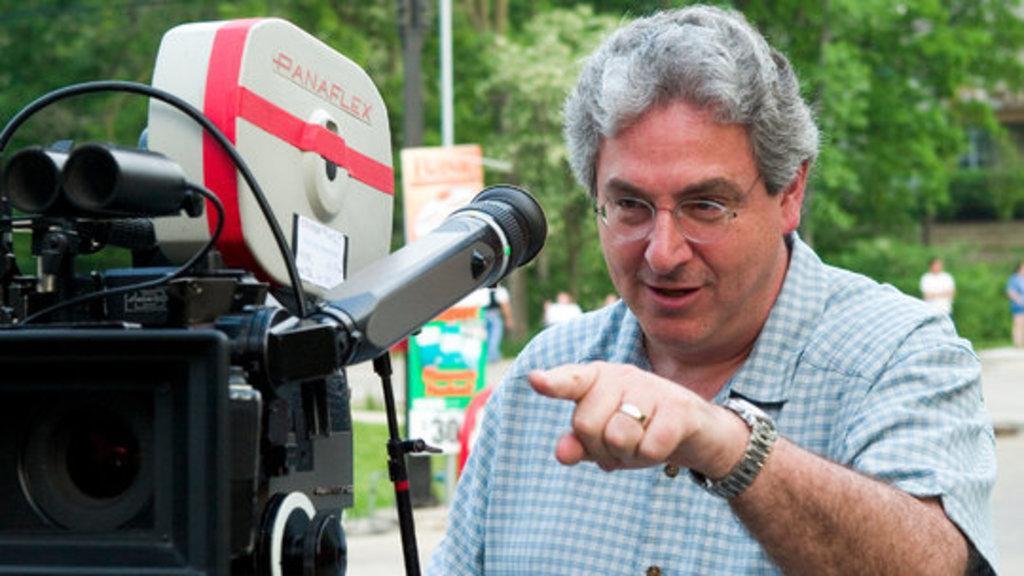Describe this image in one or two sentences. This picture might be taken from outside of the city. In this image, on the left side, we can see a camera. In the middle of the image, we can see a man wearing blue color shirt. In the background, we can see a hoardings, trees, buildings, a group of people, pole. At the bottom, we can see a road and a grass. 